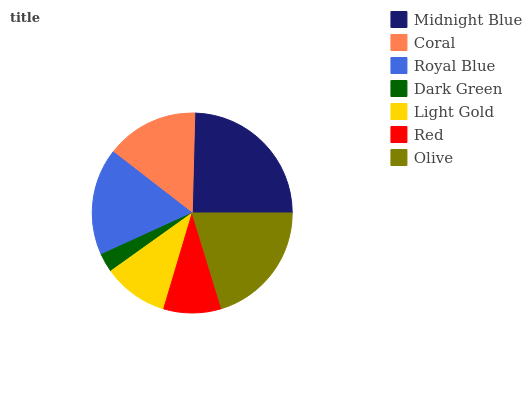Is Dark Green the minimum?
Answer yes or no. Yes. Is Midnight Blue the maximum?
Answer yes or no. Yes. Is Coral the minimum?
Answer yes or no. No. Is Coral the maximum?
Answer yes or no. No. Is Midnight Blue greater than Coral?
Answer yes or no. Yes. Is Coral less than Midnight Blue?
Answer yes or no. Yes. Is Coral greater than Midnight Blue?
Answer yes or no. No. Is Midnight Blue less than Coral?
Answer yes or no. No. Is Coral the high median?
Answer yes or no. Yes. Is Coral the low median?
Answer yes or no. Yes. Is Royal Blue the high median?
Answer yes or no. No. Is Dark Green the low median?
Answer yes or no. No. 